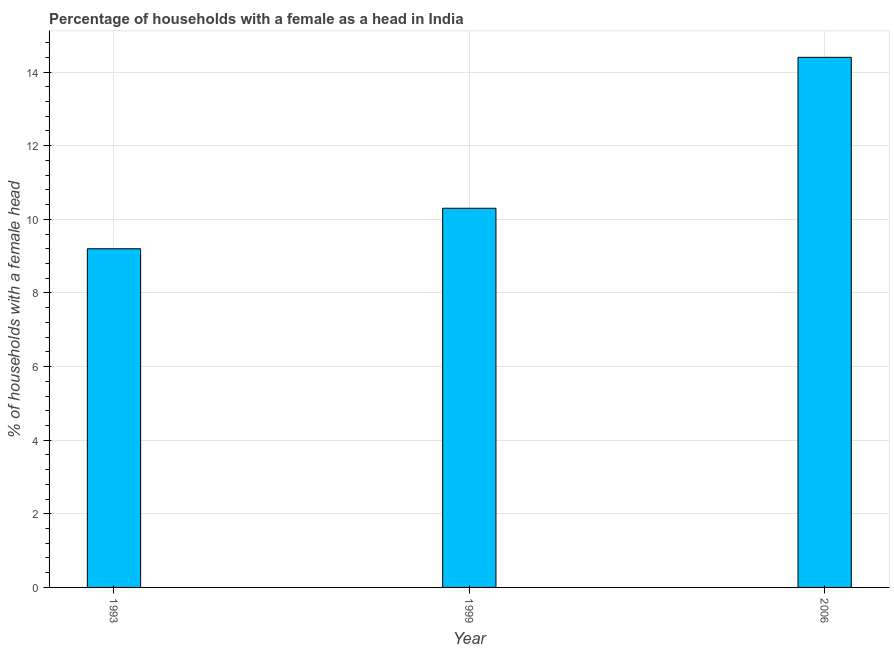Does the graph contain any zero values?
Provide a succinct answer. No. What is the title of the graph?
Offer a very short reply. Percentage of households with a female as a head in India. What is the label or title of the Y-axis?
Offer a very short reply. % of households with a female head. Across all years, what is the maximum number of female supervised households?
Make the answer very short. 14.4. Across all years, what is the minimum number of female supervised households?
Your response must be concise. 9.2. In which year was the number of female supervised households minimum?
Ensure brevity in your answer.  1993. What is the sum of the number of female supervised households?
Provide a succinct answer. 33.9. What is the difference between the number of female supervised households in 1993 and 2006?
Provide a short and direct response. -5.2. What is the average number of female supervised households per year?
Provide a short and direct response. 11.3. In how many years, is the number of female supervised households greater than 10.8 %?
Offer a very short reply. 1. What is the ratio of the number of female supervised households in 1999 to that in 2006?
Offer a terse response. 0.71. Is the number of female supervised households in 1993 less than that in 2006?
Provide a succinct answer. Yes. Is the difference between the number of female supervised households in 1993 and 2006 greater than the difference between any two years?
Make the answer very short. Yes. Is the sum of the number of female supervised households in 1993 and 1999 greater than the maximum number of female supervised households across all years?
Give a very brief answer. Yes. What is the difference between the highest and the lowest number of female supervised households?
Give a very brief answer. 5.2. How many bars are there?
Offer a terse response. 3. Are all the bars in the graph horizontal?
Your answer should be very brief. No. What is the difference between two consecutive major ticks on the Y-axis?
Offer a very short reply. 2. What is the % of households with a female head in 2006?
Provide a short and direct response. 14.4. What is the difference between the % of households with a female head in 1993 and 1999?
Give a very brief answer. -1.1. What is the difference between the % of households with a female head in 1999 and 2006?
Provide a succinct answer. -4.1. What is the ratio of the % of households with a female head in 1993 to that in 1999?
Give a very brief answer. 0.89. What is the ratio of the % of households with a female head in 1993 to that in 2006?
Provide a short and direct response. 0.64. What is the ratio of the % of households with a female head in 1999 to that in 2006?
Give a very brief answer. 0.71. 